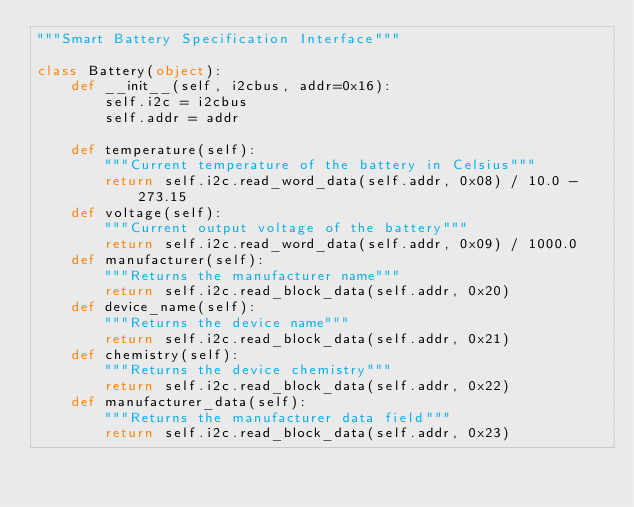<code> <loc_0><loc_0><loc_500><loc_500><_Python_>"""Smart Battery Specification Interface"""

class Battery(object):
    def __init__(self, i2cbus, addr=0x16):
        self.i2c = i2cbus
        self.addr = addr

    def temperature(self):
        """Current temperature of the battery in Celsius"""
        return self.i2c.read_word_data(self.addr, 0x08) / 10.0 - 273.15
    def voltage(self):
        """Current output voltage of the battery"""
        return self.i2c.read_word_data(self.addr, 0x09) / 1000.0
    def manufacturer(self):
        """Returns the manufacturer name"""
        return self.i2c.read_block_data(self.addr, 0x20)
    def device_name(self):
        """Returns the device name"""
        return self.i2c.read_block_data(self.addr, 0x21)
    def chemistry(self):
        """Returns the device chemistry"""
        return self.i2c.read_block_data(self.addr, 0x22)
    def manufacturer_data(self):
        """Returns the manufacturer data field"""
        return self.i2c.read_block_data(self.addr, 0x23)
</code> 